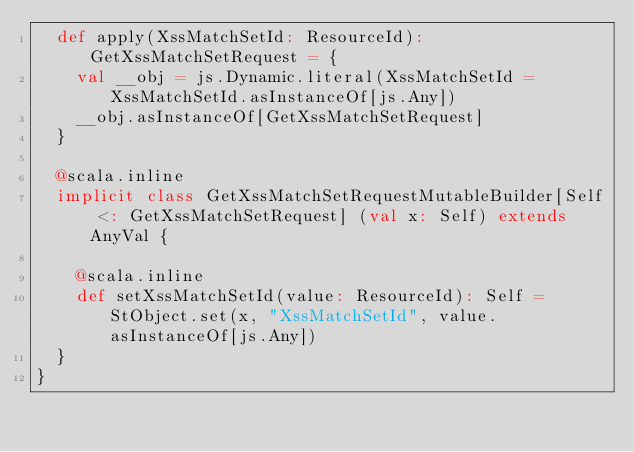<code> <loc_0><loc_0><loc_500><loc_500><_Scala_>  def apply(XssMatchSetId: ResourceId): GetXssMatchSetRequest = {
    val __obj = js.Dynamic.literal(XssMatchSetId = XssMatchSetId.asInstanceOf[js.Any])
    __obj.asInstanceOf[GetXssMatchSetRequest]
  }
  
  @scala.inline
  implicit class GetXssMatchSetRequestMutableBuilder[Self <: GetXssMatchSetRequest] (val x: Self) extends AnyVal {
    
    @scala.inline
    def setXssMatchSetId(value: ResourceId): Self = StObject.set(x, "XssMatchSetId", value.asInstanceOf[js.Any])
  }
}
</code> 